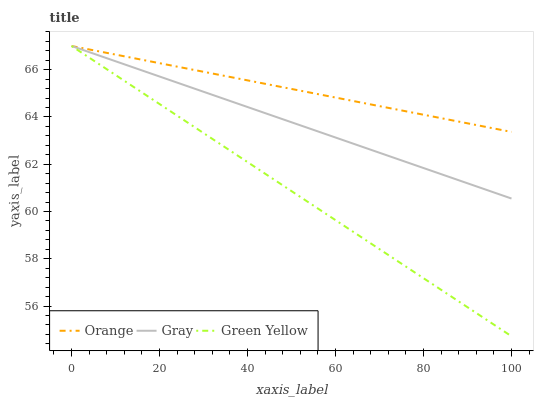Does Green Yellow have the minimum area under the curve?
Answer yes or no. Yes. Does Orange have the maximum area under the curve?
Answer yes or no. Yes. Does Gray have the minimum area under the curve?
Answer yes or no. No. Does Gray have the maximum area under the curve?
Answer yes or no. No. Is Orange the smoothest?
Answer yes or no. Yes. Is Green Yellow the roughest?
Answer yes or no. Yes. Is Gray the smoothest?
Answer yes or no. No. Is Gray the roughest?
Answer yes or no. No. Does Green Yellow have the lowest value?
Answer yes or no. Yes. Does Gray have the lowest value?
Answer yes or no. No. Does Green Yellow have the highest value?
Answer yes or no. Yes. Does Gray intersect Orange?
Answer yes or no. Yes. Is Gray less than Orange?
Answer yes or no. No. Is Gray greater than Orange?
Answer yes or no. No. 